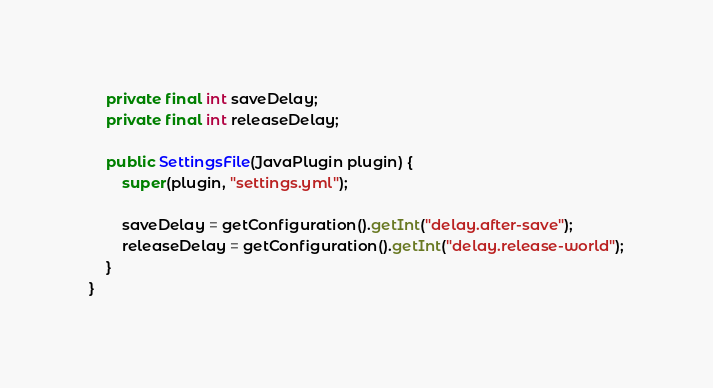<code> <loc_0><loc_0><loc_500><loc_500><_Java_>
    private final int saveDelay;
    private final int releaseDelay;

    public SettingsFile(JavaPlugin plugin) {
        super(plugin, "settings.yml");

        saveDelay = getConfiguration().getInt("delay.after-save");
        releaseDelay = getConfiguration().getInt("delay.release-world");
    }
}
</code> 